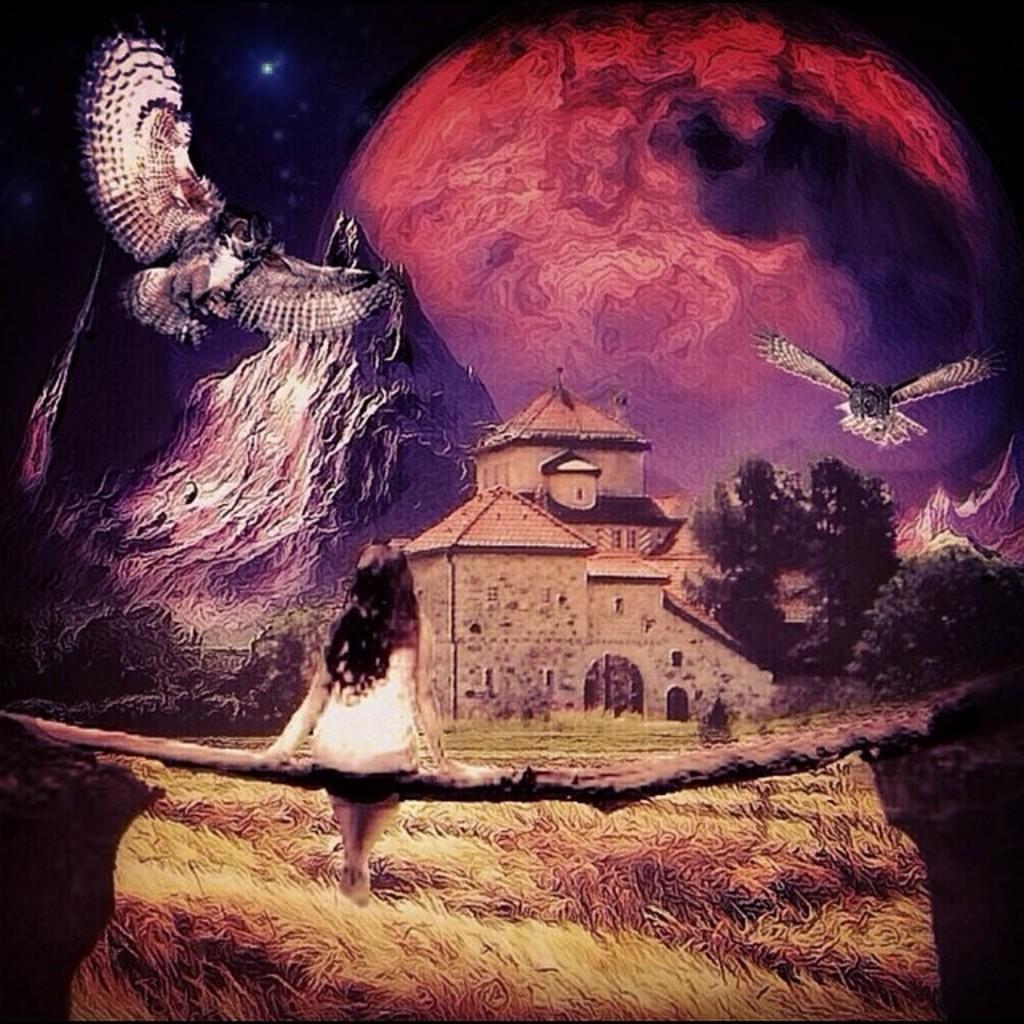How would you summarize this image in a sentence or two? This is a painting in this image there is one girl who is sitting, and in the background there is a house, trees, mountains and two birds are flying. At the bottom there are plants. 